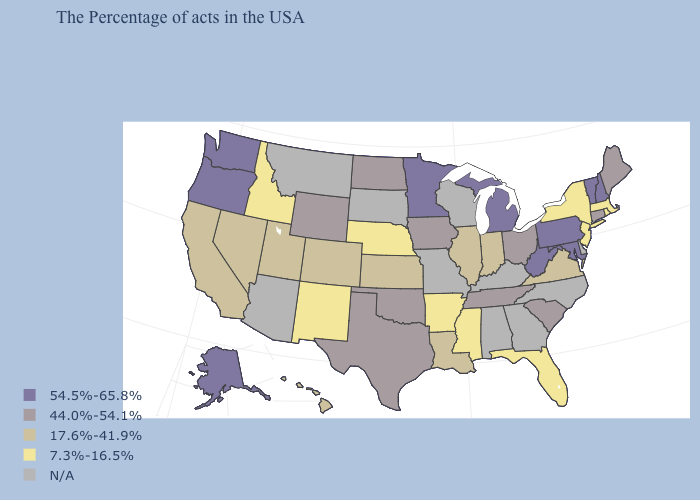Name the states that have a value in the range 54.5%-65.8%?
Write a very short answer. New Hampshire, Vermont, Maryland, Pennsylvania, West Virginia, Michigan, Minnesota, Washington, Oregon, Alaska. Name the states that have a value in the range 7.3%-16.5%?
Quick response, please. Massachusetts, Rhode Island, New York, New Jersey, Florida, Mississippi, Arkansas, Nebraska, New Mexico, Idaho. Does the first symbol in the legend represent the smallest category?
Quick response, please. No. What is the value of Hawaii?
Quick response, please. 17.6%-41.9%. Which states have the lowest value in the USA?
Keep it brief. Massachusetts, Rhode Island, New York, New Jersey, Florida, Mississippi, Arkansas, Nebraska, New Mexico, Idaho. Among the states that border Illinois , does Indiana have the lowest value?
Keep it brief. Yes. Which states hav the highest value in the South?
Keep it brief. Maryland, West Virginia. Among the states that border Indiana , does Illinois have the highest value?
Be succinct. No. Name the states that have a value in the range 17.6%-41.9%?
Write a very short answer. Virginia, Indiana, Illinois, Louisiana, Kansas, Colorado, Utah, Nevada, California, Hawaii. Does Washington have the highest value in the West?
Be succinct. Yes. Name the states that have a value in the range 7.3%-16.5%?
Give a very brief answer. Massachusetts, Rhode Island, New York, New Jersey, Florida, Mississippi, Arkansas, Nebraska, New Mexico, Idaho. What is the value of Nevada?
Give a very brief answer. 17.6%-41.9%. 